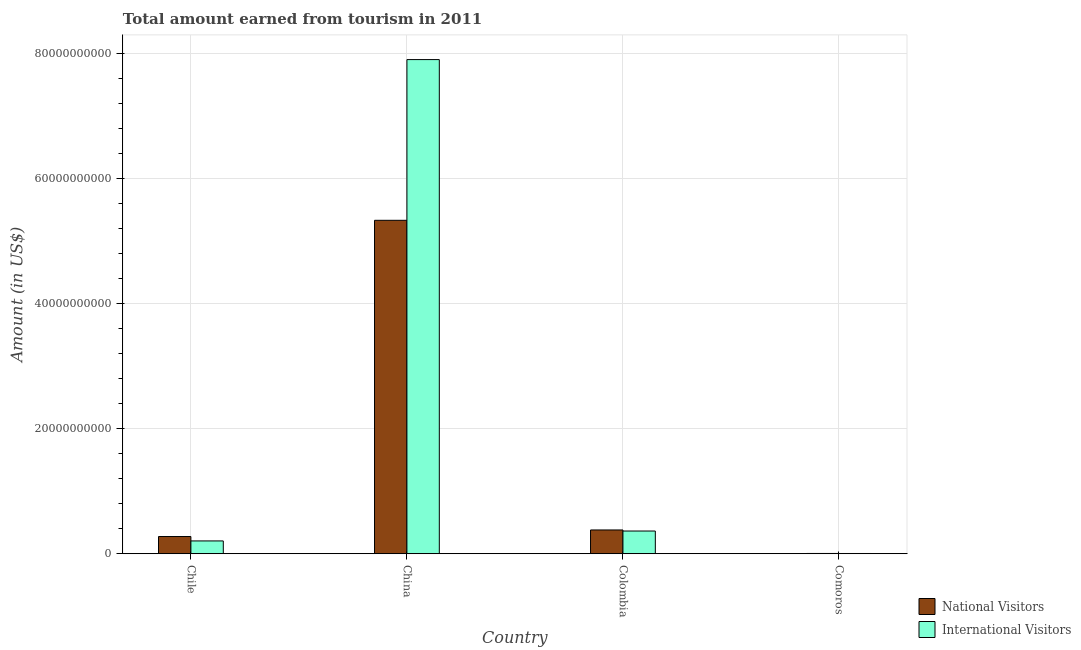Are the number of bars on each tick of the X-axis equal?
Your answer should be compact. Yes. How many bars are there on the 3rd tick from the left?
Ensure brevity in your answer.  2. How many bars are there on the 3rd tick from the right?
Keep it short and to the point. 2. In how many cases, is the number of bars for a given country not equal to the number of legend labels?
Give a very brief answer. 0. What is the amount earned from national visitors in China?
Your response must be concise. 5.33e+1. Across all countries, what is the maximum amount earned from national visitors?
Offer a terse response. 5.33e+1. Across all countries, what is the minimum amount earned from national visitors?
Make the answer very short. 4.22e+07. In which country was the amount earned from national visitors maximum?
Keep it short and to the point. China. In which country was the amount earned from international visitors minimum?
Your answer should be very brief. Comoros. What is the total amount earned from national visitors in the graph?
Offer a terse response. 5.99e+1. What is the difference between the amount earned from international visitors in Chile and that in China?
Your response must be concise. -7.70e+1. What is the difference between the amount earned from international visitors in China and the amount earned from national visitors in Comoros?
Your answer should be compact. 7.90e+1. What is the average amount earned from international visitors per country?
Your answer should be compact. 2.12e+1. What is the difference between the amount earned from national visitors and amount earned from international visitors in Comoros?
Ensure brevity in your answer.  5.20e+06. In how many countries, is the amount earned from international visitors greater than 4000000000 US$?
Your answer should be compact. 1. What is the ratio of the amount earned from national visitors in Chile to that in Comoros?
Provide a succinct answer. 65.19. Is the amount earned from international visitors in Colombia less than that in Comoros?
Make the answer very short. No. What is the difference between the highest and the second highest amount earned from international visitors?
Give a very brief answer. 7.54e+1. What is the difference between the highest and the lowest amount earned from international visitors?
Offer a very short reply. 7.90e+1. Is the sum of the amount earned from national visitors in China and Colombia greater than the maximum amount earned from international visitors across all countries?
Provide a short and direct response. No. What does the 2nd bar from the left in Colombia represents?
Provide a short and direct response. International Visitors. What does the 2nd bar from the right in Colombia represents?
Provide a succinct answer. National Visitors. How many bars are there?
Your response must be concise. 8. How many countries are there in the graph?
Offer a terse response. 4. What is the difference between two consecutive major ticks on the Y-axis?
Ensure brevity in your answer.  2.00e+1. Are the values on the major ticks of Y-axis written in scientific E-notation?
Provide a succinct answer. No. Does the graph contain grids?
Your answer should be compact. Yes. Where does the legend appear in the graph?
Your response must be concise. Bottom right. How many legend labels are there?
Provide a succinct answer. 2. What is the title of the graph?
Provide a succinct answer. Total amount earned from tourism in 2011. What is the Amount (in US$) of National Visitors in Chile?
Ensure brevity in your answer.  2.75e+09. What is the Amount (in US$) in International Visitors in Chile?
Your answer should be very brief. 2.05e+09. What is the Amount (in US$) in National Visitors in China?
Keep it short and to the point. 5.33e+1. What is the Amount (in US$) in International Visitors in China?
Ensure brevity in your answer.  7.90e+1. What is the Amount (in US$) in National Visitors in Colombia?
Ensure brevity in your answer.  3.80e+09. What is the Amount (in US$) in International Visitors in Colombia?
Provide a succinct answer. 3.63e+09. What is the Amount (in US$) in National Visitors in Comoros?
Provide a succinct answer. 4.22e+07. What is the Amount (in US$) in International Visitors in Comoros?
Offer a very short reply. 3.70e+07. Across all countries, what is the maximum Amount (in US$) in National Visitors?
Keep it short and to the point. 5.33e+1. Across all countries, what is the maximum Amount (in US$) of International Visitors?
Provide a short and direct response. 7.90e+1. Across all countries, what is the minimum Amount (in US$) in National Visitors?
Your answer should be very brief. 4.22e+07. Across all countries, what is the minimum Amount (in US$) in International Visitors?
Keep it short and to the point. 3.70e+07. What is the total Amount (in US$) in National Visitors in the graph?
Provide a short and direct response. 5.99e+1. What is the total Amount (in US$) of International Visitors in the graph?
Ensure brevity in your answer.  8.47e+1. What is the difference between the Amount (in US$) in National Visitors in Chile and that in China?
Offer a terse response. -5.06e+1. What is the difference between the Amount (in US$) of International Visitors in Chile and that in China?
Ensure brevity in your answer.  -7.70e+1. What is the difference between the Amount (in US$) of National Visitors in Chile and that in Colombia?
Make the answer very short. -1.05e+09. What is the difference between the Amount (in US$) of International Visitors in Chile and that in Colombia?
Give a very brief answer. -1.58e+09. What is the difference between the Amount (in US$) of National Visitors in Chile and that in Comoros?
Ensure brevity in your answer.  2.71e+09. What is the difference between the Amount (in US$) of International Visitors in Chile and that in Comoros?
Make the answer very short. 2.01e+09. What is the difference between the Amount (in US$) in National Visitors in China and that in Colombia?
Ensure brevity in your answer.  4.95e+1. What is the difference between the Amount (in US$) in International Visitors in China and that in Colombia?
Ensure brevity in your answer.  7.54e+1. What is the difference between the Amount (in US$) of National Visitors in China and that in Comoros?
Keep it short and to the point. 5.33e+1. What is the difference between the Amount (in US$) in International Visitors in China and that in Comoros?
Your answer should be very brief. 7.90e+1. What is the difference between the Amount (in US$) of National Visitors in Colombia and that in Comoros?
Provide a short and direct response. 3.76e+09. What is the difference between the Amount (in US$) in International Visitors in Colombia and that in Comoros?
Keep it short and to the point. 3.59e+09. What is the difference between the Amount (in US$) in National Visitors in Chile and the Amount (in US$) in International Visitors in China?
Ensure brevity in your answer.  -7.63e+1. What is the difference between the Amount (in US$) in National Visitors in Chile and the Amount (in US$) in International Visitors in Colombia?
Offer a very short reply. -8.80e+08. What is the difference between the Amount (in US$) of National Visitors in Chile and the Amount (in US$) of International Visitors in Comoros?
Your response must be concise. 2.71e+09. What is the difference between the Amount (in US$) in National Visitors in China and the Amount (in US$) in International Visitors in Colombia?
Keep it short and to the point. 4.97e+1. What is the difference between the Amount (in US$) of National Visitors in China and the Amount (in US$) of International Visitors in Comoros?
Offer a terse response. 5.33e+1. What is the difference between the Amount (in US$) in National Visitors in Colombia and the Amount (in US$) in International Visitors in Comoros?
Ensure brevity in your answer.  3.76e+09. What is the average Amount (in US$) in National Visitors per country?
Make the answer very short. 1.50e+1. What is the average Amount (in US$) of International Visitors per country?
Provide a succinct answer. 2.12e+1. What is the difference between the Amount (in US$) of National Visitors and Amount (in US$) of International Visitors in Chile?
Offer a very short reply. 7.04e+08. What is the difference between the Amount (in US$) of National Visitors and Amount (in US$) of International Visitors in China?
Offer a very short reply. -2.57e+1. What is the difference between the Amount (in US$) in National Visitors and Amount (in US$) in International Visitors in Colombia?
Ensure brevity in your answer.  1.70e+08. What is the difference between the Amount (in US$) in National Visitors and Amount (in US$) in International Visitors in Comoros?
Your answer should be very brief. 5.20e+06. What is the ratio of the Amount (in US$) of National Visitors in Chile to that in China?
Provide a succinct answer. 0.05. What is the ratio of the Amount (in US$) in International Visitors in Chile to that in China?
Your response must be concise. 0.03. What is the ratio of the Amount (in US$) in National Visitors in Chile to that in Colombia?
Keep it short and to the point. 0.72. What is the ratio of the Amount (in US$) in International Visitors in Chile to that in Colombia?
Ensure brevity in your answer.  0.56. What is the ratio of the Amount (in US$) of National Visitors in Chile to that in Comoros?
Keep it short and to the point. 65.19. What is the ratio of the Amount (in US$) of International Visitors in Chile to that in Comoros?
Keep it short and to the point. 55.32. What is the ratio of the Amount (in US$) of National Visitors in China to that in Colombia?
Provide a succinct answer. 14.03. What is the ratio of the Amount (in US$) in International Visitors in China to that in Colombia?
Ensure brevity in your answer.  21.76. What is the ratio of the Amount (in US$) of National Visitors in China to that in Comoros?
Keep it short and to the point. 1263.34. What is the ratio of the Amount (in US$) in International Visitors in China to that in Comoros?
Provide a short and direct response. 2135.41. What is the ratio of the Amount (in US$) in National Visitors in Colombia to that in Comoros?
Provide a succinct answer. 90.07. What is the ratio of the Amount (in US$) in International Visitors in Colombia to that in Comoros?
Your answer should be very brief. 98.14. What is the difference between the highest and the second highest Amount (in US$) of National Visitors?
Make the answer very short. 4.95e+1. What is the difference between the highest and the second highest Amount (in US$) of International Visitors?
Keep it short and to the point. 7.54e+1. What is the difference between the highest and the lowest Amount (in US$) of National Visitors?
Ensure brevity in your answer.  5.33e+1. What is the difference between the highest and the lowest Amount (in US$) in International Visitors?
Offer a terse response. 7.90e+1. 